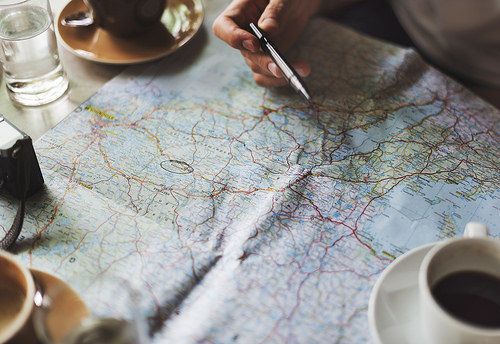<image>
Is there a pen above the map? Yes. The pen is positioned above the map in the vertical space, higher up in the scene. 